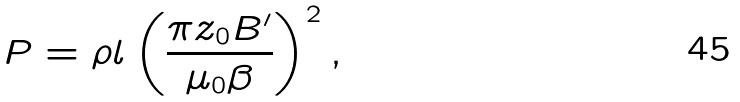<formula> <loc_0><loc_0><loc_500><loc_500>P = \rho l \left ( \frac { \pi z _ { 0 } B ^ { \prime } } { \mu _ { 0 } \beta } \right ) ^ { 2 } ,</formula> 